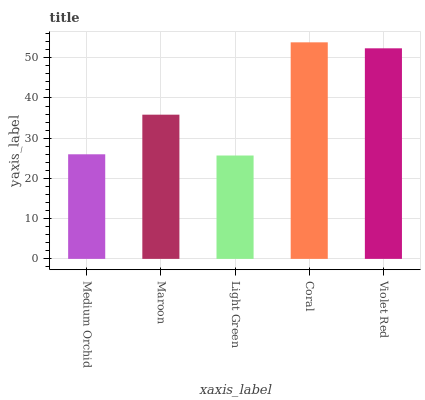Is Maroon the minimum?
Answer yes or no. No. Is Maroon the maximum?
Answer yes or no. No. Is Maroon greater than Medium Orchid?
Answer yes or no. Yes. Is Medium Orchid less than Maroon?
Answer yes or no. Yes. Is Medium Orchid greater than Maroon?
Answer yes or no. No. Is Maroon less than Medium Orchid?
Answer yes or no. No. Is Maroon the high median?
Answer yes or no. Yes. Is Maroon the low median?
Answer yes or no. Yes. Is Coral the high median?
Answer yes or no. No. Is Medium Orchid the low median?
Answer yes or no. No. 